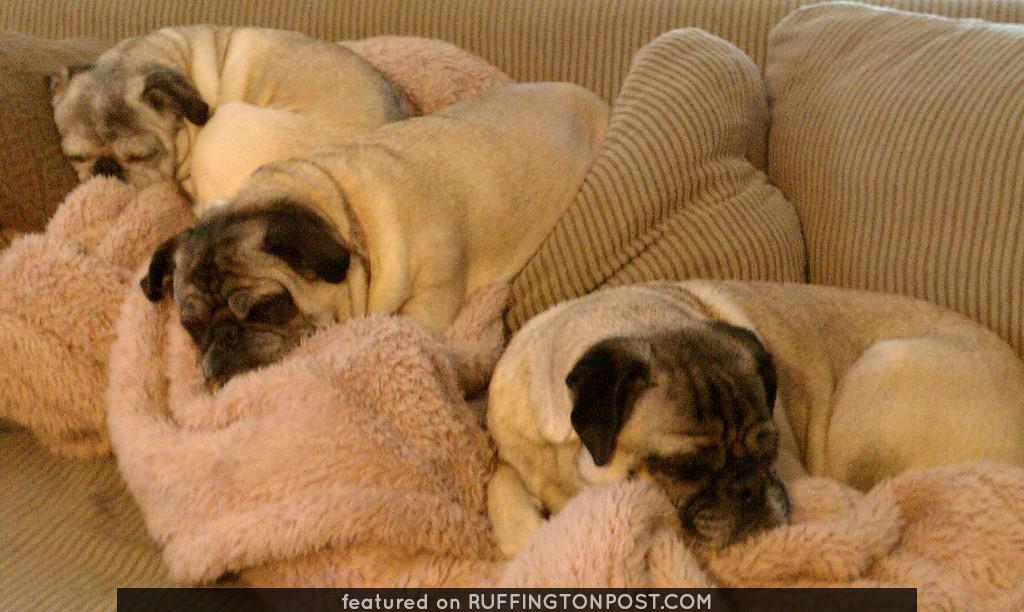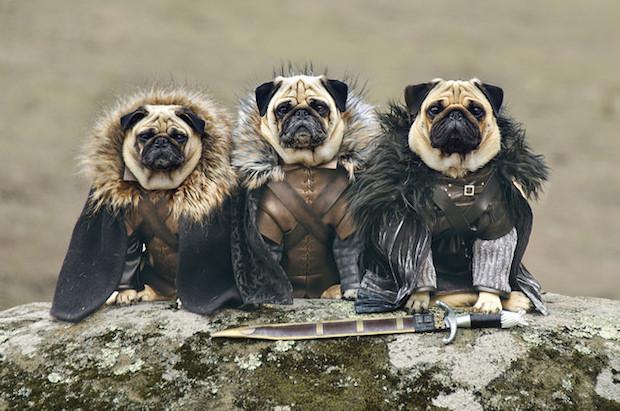The first image is the image on the left, the second image is the image on the right. Assess this claim about the two images: "The dogs in the image on the right are wearing winter coats.". Correct or not? Answer yes or no. Yes. The first image is the image on the left, the second image is the image on the right. Considering the images on both sides, is "Three pugs are posed in a row wearing outfits with fur collars." valid? Answer yes or no. Yes. 